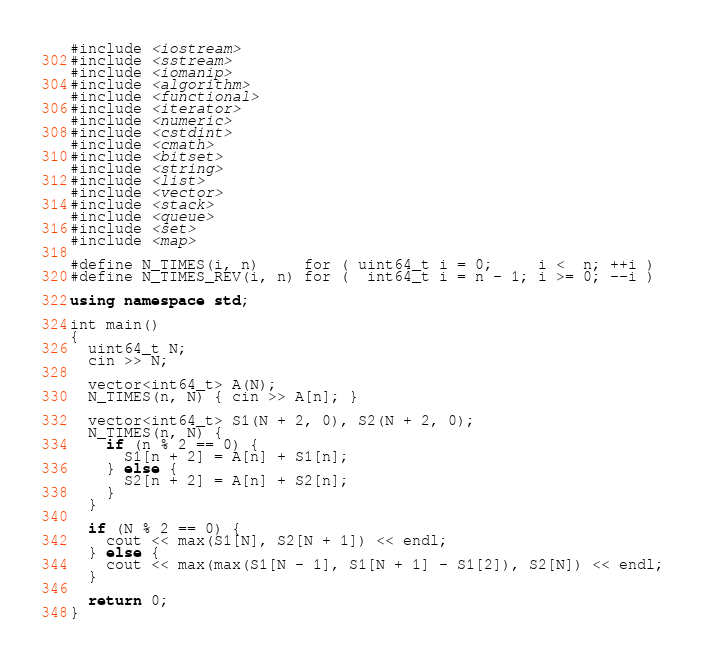<code> <loc_0><loc_0><loc_500><loc_500><_C++_>#include <iostream>
#include <sstream>
#include <iomanip>
#include <algorithm>
#include <functional>
#include <iterator>
#include <numeric>
#include <cstdint>
#include <cmath>
#include <bitset>
#include <string>
#include <list>
#include <vector>
#include <stack>
#include <queue>
#include <set>
#include <map>

#define N_TIMES(i, n)     for ( uint64_t i = 0;     i <  n; ++i )
#define N_TIMES_REV(i, n) for (  int64_t i = n - 1; i >= 0; --i )

using namespace std;

int main()
{
  uint64_t N;
  cin >> N;

  vector<int64_t> A(N);
  N_TIMES(n, N) { cin >> A[n]; }

  vector<int64_t> S1(N + 2, 0), S2(N + 2, 0);
  N_TIMES(n, N) {
    if (n % 2 == 0) {
      S1[n + 2] = A[n] + S1[n];
    } else {
      S2[n + 2] = A[n] + S2[n];
    }
  }

  if (N % 2 == 0) {
    cout << max(S1[N], S2[N + 1]) << endl;
  } else {
    cout << max(max(S1[N - 1], S1[N + 1] - S1[2]), S2[N]) << endl;
  }

  return 0;
}</code> 